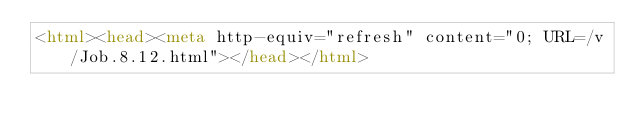Convert code to text. <code><loc_0><loc_0><loc_500><loc_500><_HTML_><html><head><meta http-equiv="refresh" content="0; URL=/v/Job.8.12.html"></head></html></code> 